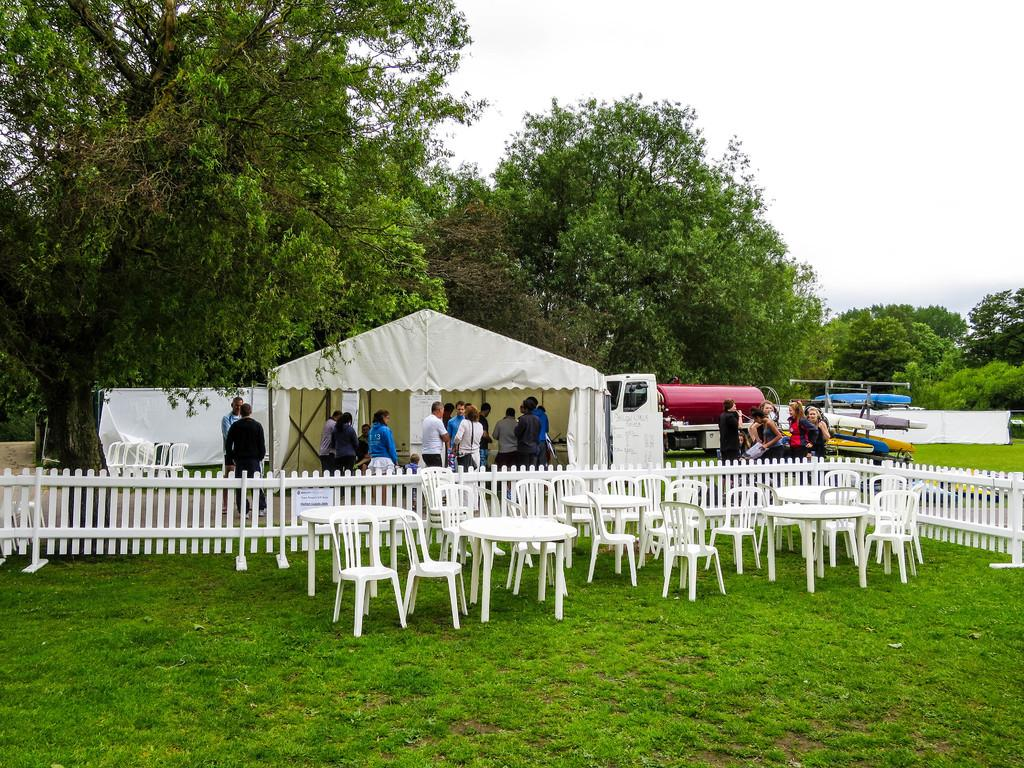What is the primary surface visible in the image? There is a ground in the image. What objects are placed on the ground? There are chairs on the ground. What can be seen in the background of the image? There are people, trees, and a vehicle in the background of the image. What type of structure is present in the image? There is a tent house in the image. What type of pancake is being used to illuminate the tent house in the image? There is no pancake present in the image, and pancakes are not used for illumination purposes. 